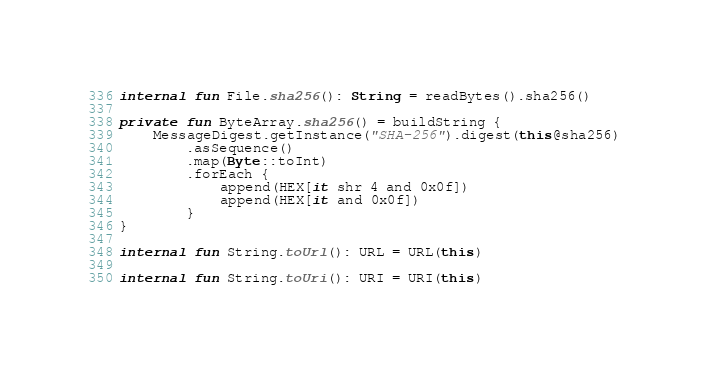<code> <loc_0><loc_0><loc_500><loc_500><_Kotlin_>internal fun File.sha256(): String = readBytes().sha256()

private fun ByteArray.sha256() = buildString {
    MessageDigest.getInstance("SHA-256").digest(this@sha256)
        .asSequence()
        .map(Byte::toInt)
        .forEach {
            append(HEX[it shr 4 and 0x0f])
            append(HEX[it and 0x0f])
        }
}

internal fun String.toUrl(): URL = URL(this)

internal fun String.toUri(): URI = URI(this)
</code> 